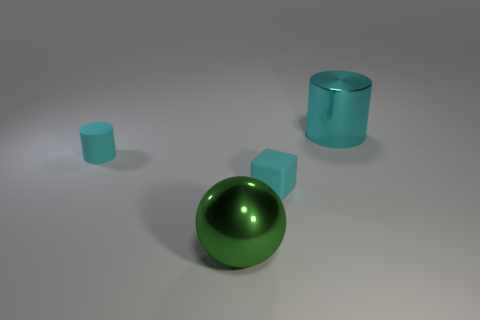Are the big cylinder and the tiny cylinder made of the same material?
Your answer should be compact. No. There is another matte thing that is the same shape as the large cyan thing; what size is it?
Your answer should be compact. Small. There is a small thing that is behind the cyan rubber block; is it the same shape as the large object behind the tiny cylinder?
Offer a very short reply. Yes. Is the size of the green ball the same as the cyan cylinder that is right of the block?
Give a very brief answer. Yes. How many other things are there of the same material as the big green sphere?
Make the answer very short. 1. Are there any other things that are the same shape as the green shiny thing?
Provide a succinct answer. No. The thing that is in front of the cyan matte object in front of the thing on the left side of the large green shiny thing is what color?
Give a very brief answer. Green. There is a object that is both in front of the rubber cylinder and to the right of the big green thing; what is its shape?
Provide a succinct answer. Cube. The tiny matte object that is on the right side of the cyan rubber thing on the left side of the ball is what color?
Your answer should be compact. Cyan. There is a large object that is on the left side of the thing behind the tiny cyan object that is to the left of the big green shiny sphere; what is its shape?
Ensure brevity in your answer.  Sphere. 